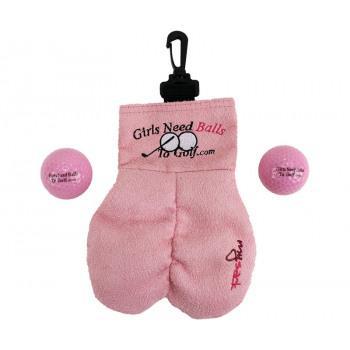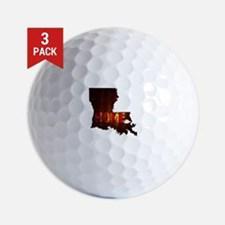The first image is the image on the left, the second image is the image on the right. Considering the images on both sides, is "An image shows one brown sack next to a pair of balls." valid? Answer yes or no. No. The first image is the image on the left, the second image is the image on the right. Assess this claim about the two images: "There are exactly 4 golf balls.". Correct or not? Answer yes or no. No. 